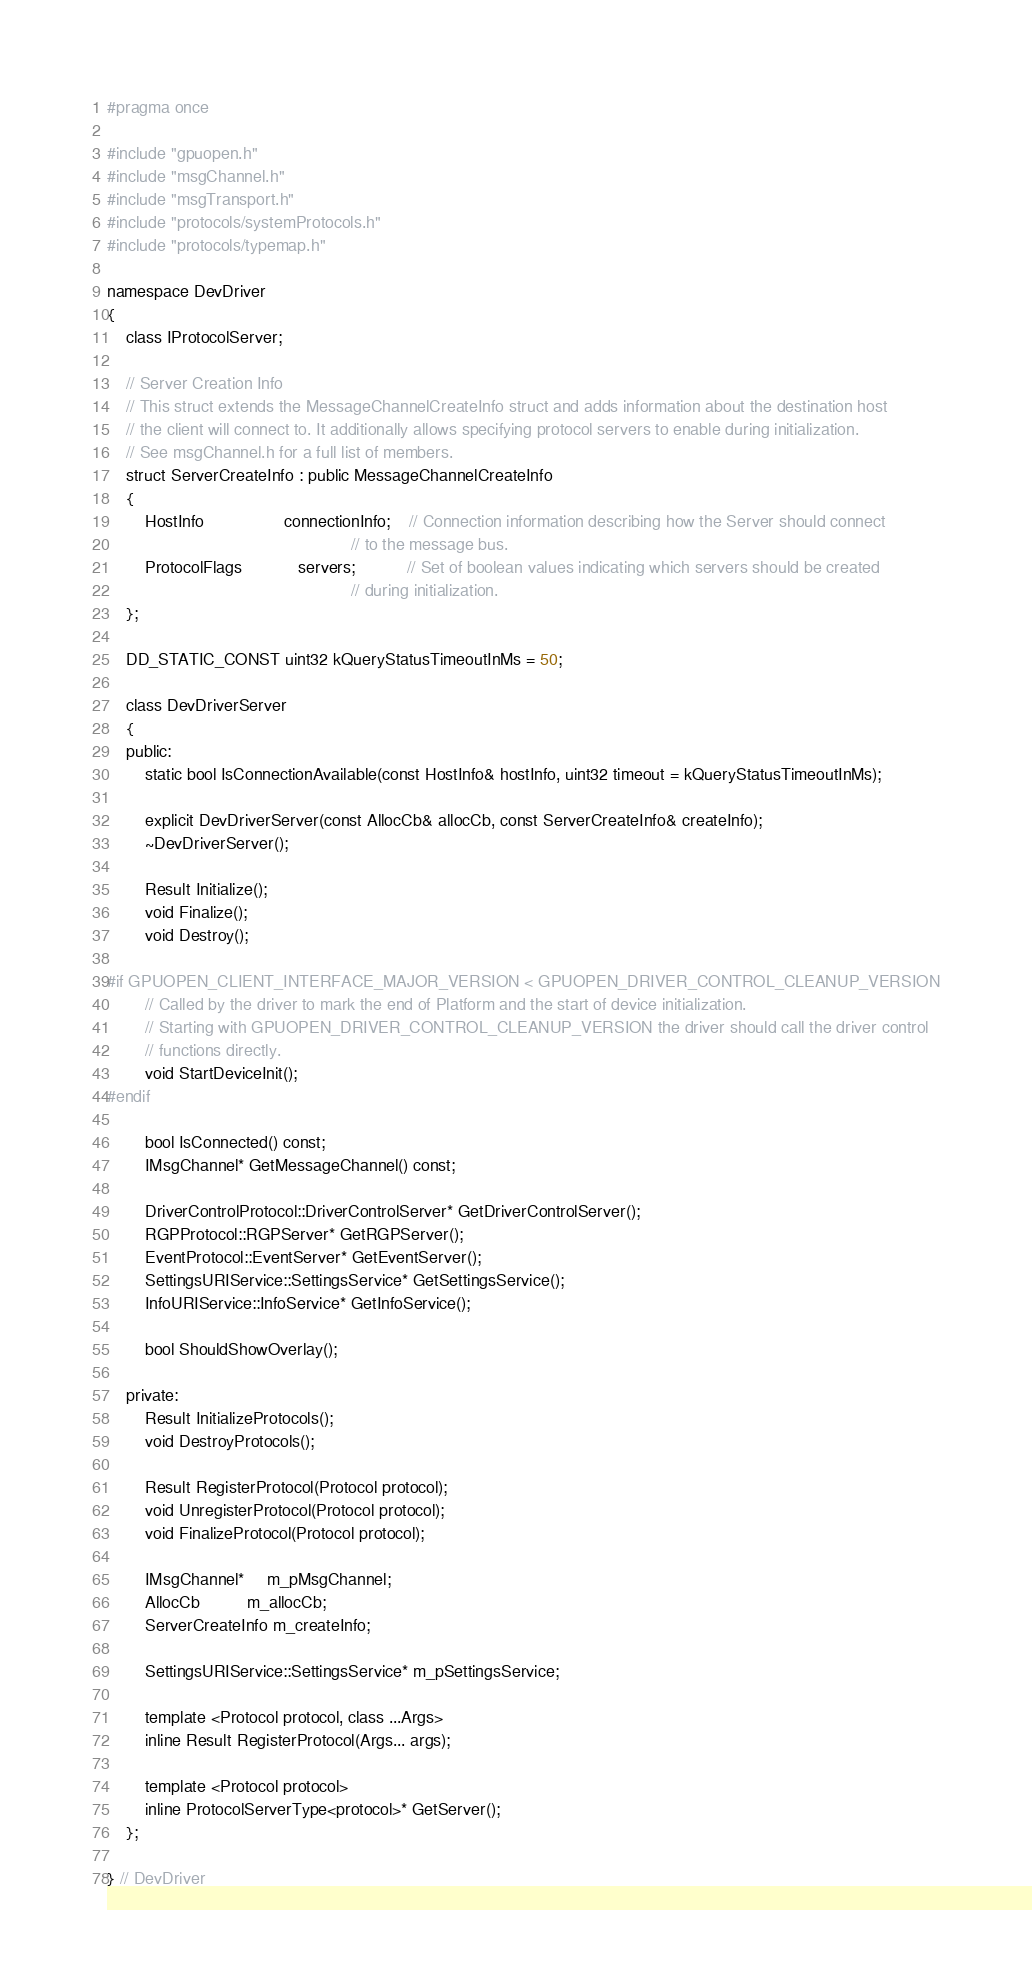<code> <loc_0><loc_0><loc_500><loc_500><_C_>#pragma once

#include "gpuopen.h"
#include "msgChannel.h"
#include "msgTransport.h"
#include "protocols/systemProtocols.h"
#include "protocols/typemap.h"

namespace DevDriver
{
    class IProtocolServer;

    // Server Creation Info
    // This struct extends the MessageChannelCreateInfo struct and adds information about the destination host
    // the client will connect to. It additionally allows specifying protocol servers to enable during initialization.
    // See msgChannel.h for a full list of members.
    struct ServerCreateInfo : public MessageChannelCreateInfo
    {
        HostInfo                 connectionInfo;    // Connection information describing how the Server should connect
                                                    // to the message bus.
        ProtocolFlags            servers;           // Set of boolean values indicating which servers should be created
                                                    // during initialization.
    };

    DD_STATIC_CONST uint32 kQueryStatusTimeoutInMs = 50;

    class DevDriverServer
    {
    public:
        static bool IsConnectionAvailable(const HostInfo& hostInfo, uint32 timeout = kQueryStatusTimeoutInMs);

        explicit DevDriverServer(const AllocCb& allocCb, const ServerCreateInfo& createInfo);
        ~DevDriverServer();

        Result Initialize();
        void Finalize();
        void Destroy();

#if GPUOPEN_CLIENT_INTERFACE_MAJOR_VERSION < GPUOPEN_DRIVER_CONTROL_CLEANUP_VERSION
        // Called by the driver to mark the end of Platform and the start of device initialization.
        // Starting with GPUOPEN_DRIVER_CONTROL_CLEANUP_VERSION the driver should call the driver control
        // functions directly.
        void StartDeviceInit();
#endif

        bool IsConnected() const;
        IMsgChannel* GetMessageChannel() const;

        DriverControlProtocol::DriverControlServer* GetDriverControlServer();
        RGPProtocol::RGPServer* GetRGPServer();
        EventProtocol::EventServer* GetEventServer();
        SettingsURIService::SettingsService* GetSettingsService();
        InfoURIService::InfoService* GetInfoService();

        bool ShouldShowOverlay();

    private:
        Result InitializeProtocols();
        void DestroyProtocols();

        Result RegisterProtocol(Protocol protocol);
        void UnregisterProtocol(Protocol protocol);
        void FinalizeProtocol(Protocol protocol);

        IMsgChannel*     m_pMsgChannel;
        AllocCb          m_allocCb;
        ServerCreateInfo m_createInfo;

        SettingsURIService::SettingsService* m_pSettingsService;

        template <Protocol protocol, class ...Args>
        inline Result RegisterProtocol(Args... args);

        template <Protocol protocol>
        inline ProtocolServerType<protocol>* GetServer();
    };

} // DevDriver
</code> 